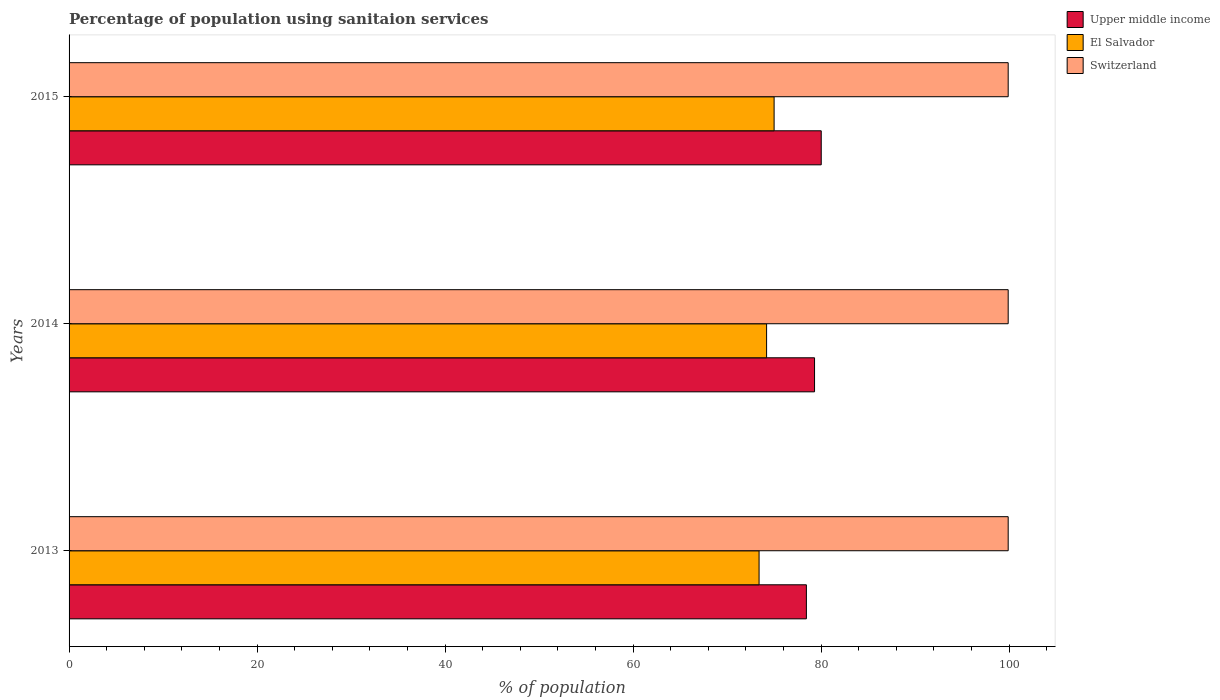How many different coloured bars are there?
Your answer should be very brief. 3. Are the number of bars per tick equal to the number of legend labels?
Your answer should be compact. Yes. What is the label of the 2nd group of bars from the top?
Your answer should be compact. 2014. In how many cases, is the number of bars for a given year not equal to the number of legend labels?
Give a very brief answer. 0. What is the percentage of population using sanitaion services in Upper middle income in 2014?
Give a very brief answer. 79.3. Across all years, what is the maximum percentage of population using sanitaion services in Upper middle income?
Provide a succinct answer. 80.01. Across all years, what is the minimum percentage of population using sanitaion services in Upper middle income?
Provide a short and direct response. 78.43. What is the total percentage of population using sanitaion services in Upper middle income in the graph?
Your answer should be compact. 237.75. What is the difference between the percentage of population using sanitaion services in Switzerland in 2014 and that in 2015?
Your answer should be very brief. 0. What is the difference between the percentage of population using sanitaion services in El Salvador in 2014 and the percentage of population using sanitaion services in Switzerland in 2015?
Offer a terse response. -25.7. What is the average percentage of population using sanitaion services in Switzerland per year?
Offer a very short reply. 99.9. In the year 2015, what is the difference between the percentage of population using sanitaion services in Upper middle income and percentage of population using sanitaion services in El Salvador?
Provide a short and direct response. 5.01. In how many years, is the percentage of population using sanitaion services in Upper middle income greater than 84 %?
Your answer should be compact. 0. What is the ratio of the percentage of population using sanitaion services in Upper middle income in 2014 to that in 2015?
Your answer should be compact. 0.99. What is the difference between the highest and the second highest percentage of population using sanitaion services in Switzerland?
Offer a terse response. 0. What is the difference between the highest and the lowest percentage of population using sanitaion services in El Salvador?
Offer a very short reply. 1.6. In how many years, is the percentage of population using sanitaion services in Upper middle income greater than the average percentage of population using sanitaion services in Upper middle income taken over all years?
Offer a very short reply. 2. Is the sum of the percentage of population using sanitaion services in Switzerland in 2013 and 2015 greater than the maximum percentage of population using sanitaion services in Upper middle income across all years?
Make the answer very short. Yes. What does the 3rd bar from the top in 2013 represents?
Offer a very short reply. Upper middle income. What does the 2nd bar from the bottom in 2014 represents?
Your answer should be very brief. El Salvador. How many years are there in the graph?
Provide a short and direct response. 3. Does the graph contain any zero values?
Your answer should be very brief. No. What is the title of the graph?
Keep it short and to the point. Percentage of population using sanitaion services. Does "South Sudan" appear as one of the legend labels in the graph?
Keep it short and to the point. No. What is the label or title of the X-axis?
Your answer should be compact. % of population. What is the % of population in Upper middle income in 2013?
Make the answer very short. 78.43. What is the % of population in El Salvador in 2013?
Offer a very short reply. 73.4. What is the % of population of Switzerland in 2013?
Give a very brief answer. 99.9. What is the % of population in Upper middle income in 2014?
Your response must be concise. 79.3. What is the % of population of El Salvador in 2014?
Provide a short and direct response. 74.2. What is the % of population of Switzerland in 2014?
Make the answer very short. 99.9. What is the % of population in Upper middle income in 2015?
Your answer should be compact. 80.01. What is the % of population in Switzerland in 2015?
Offer a terse response. 99.9. Across all years, what is the maximum % of population in Upper middle income?
Make the answer very short. 80.01. Across all years, what is the maximum % of population of Switzerland?
Offer a terse response. 99.9. Across all years, what is the minimum % of population in Upper middle income?
Provide a short and direct response. 78.43. Across all years, what is the minimum % of population of El Salvador?
Make the answer very short. 73.4. Across all years, what is the minimum % of population in Switzerland?
Your answer should be compact. 99.9. What is the total % of population of Upper middle income in the graph?
Keep it short and to the point. 237.75. What is the total % of population in El Salvador in the graph?
Offer a very short reply. 222.6. What is the total % of population in Switzerland in the graph?
Keep it short and to the point. 299.7. What is the difference between the % of population of Upper middle income in 2013 and that in 2014?
Make the answer very short. -0.87. What is the difference between the % of population in El Salvador in 2013 and that in 2014?
Your answer should be compact. -0.8. What is the difference between the % of population in Upper middle income in 2013 and that in 2015?
Offer a terse response. -1.58. What is the difference between the % of population in El Salvador in 2013 and that in 2015?
Your response must be concise. -1.6. What is the difference between the % of population of Upper middle income in 2014 and that in 2015?
Make the answer very short. -0.71. What is the difference between the % of population of Upper middle income in 2013 and the % of population of El Salvador in 2014?
Keep it short and to the point. 4.23. What is the difference between the % of population in Upper middle income in 2013 and the % of population in Switzerland in 2014?
Ensure brevity in your answer.  -21.47. What is the difference between the % of population in El Salvador in 2013 and the % of population in Switzerland in 2014?
Your answer should be compact. -26.5. What is the difference between the % of population of Upper middle income in 2013 and the % of population of El Salvador in 2015?
Your answer should be compact. 3.43. What is the difference between the % of population in Upper middle income in 2013 and the % of population in Switzerland in 2015?
Offer a very short reply. -21.47. What is the difference between the % of population in El Salvador in 2013 and the % of population in Switzerland in 2015?
Offer a very short reply. -26.5. What is the difference between the % of population in Upper middle income in 2014 and the % of population in El Salvador in 2015?
Give a very brief answer. 4.3. What is the difference between the % of population in Upper middle income in 2014 and the % of population in Switzerland in 2015?
Give a very brief answer. -20.6. What is the difference between the % of population in El Salvador in 2014 and the % of population in Switzerland in 2015?
Provide a succinct answer. -25.7. What is the average % of population of Upper middle income per year?
Your answer should be compact. 79.25. What is the average % of population in El Salvador per year?
Give a very brief answer. 74.2. What is the average % of population of Switzerland per year?
Your answer should be compact. 99.9. In the year 2013, what is the difference between the % of population in Upper middle income and % of population in El Salvador?
Give a very brief answer. 5.03. In the year 2013, what is the difference between the % of population of Upper middle income and % of population of Switzerland?
Your answer should be compact. -21.47. In the year 2013, what is the difference between the % of population in El Salvador and % of population in Switzerland?
Provide a short and direct response. -26.5. In the year 2014, what is the difference between the % of population in Upper middle income and % of population in El Salvador?
Your answer should be compact. 5.1. In the year 2014, what is the difference between the % of population of Upper middle income and % of population of Switzerland?
Provide a short and direct response. -20.6. In the year 2014, what is the difference between the % of population in El Salvador and % of population in Switzerland?
Give a very brief answer. -25.7. In the year 2015, what is the difference between the % of population of Upper middle income and % of population of El Salvador?
Keep it short and to the point. 5.01. In the year 2015, what is the difference between the % of population in Upper middle income and % of population in Switzerland?
Provide a short and direct response. -19.89. In the year 2015, what is the difference between the % of population of El Salvador and % of population of Switzerland?
Provide a short and direct response. -24.9. What is the ratio of the % of population in Upper middle income in 2013 to that in 2015?
Give a very brief answer. 0.98. What is the ratio of the % of population of El Salvador in 2013 to that in 2015?
Provide a succinct answer. 0.98. What is the ratio of the % of population of Upper middle income in 2014 to that in 2015?
Your answer should be compact. 0.99. What is the ratio of the % of population of El Salvador in 2014 to that in 2015?
Your answer should be compact. 0.99. What is the difference between the highest and the second highest % of population in Upper middle income?
Your response must be concise. 0.71. What is the difference between the highest and the second highest % of population in Switzerland?
Keep it short and to the point. 0. What is the difference between the highest and the lowest % of population of Upper middle income?
Your answer should be compact. 1.58. What is the difference between the highest and the lowest % of population of El Salvador?
Your answer should be very brief. 1.6. 